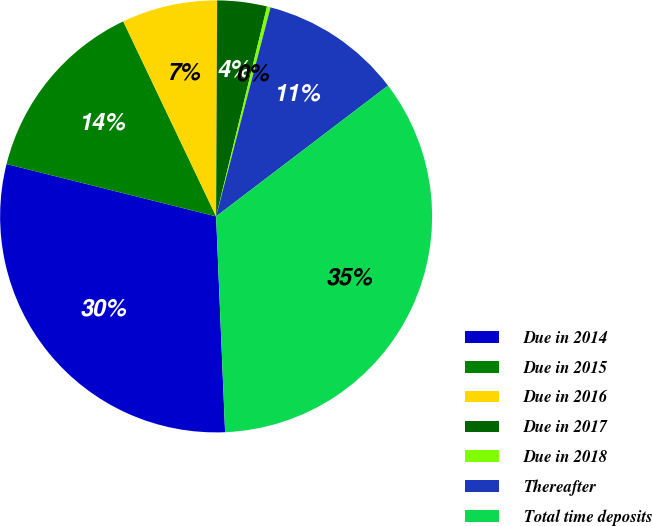<chart> <loc_0><loc_0><loc_500><loc_500><pie_chart><fcel>Due in 2014<fcel>Due in 2015<fcel>Due in 2016<fcel>Due in 2017<fcel>Due in 2018<fcel>Thereafter<fcel>Total time deposits<nl><fcel>29.56%<fcel>14.03%<fcel>7.15%<fcel>3.71%<fcel>0.27%<fcel>10.59%<fcel>34.69%<nl></chart> 